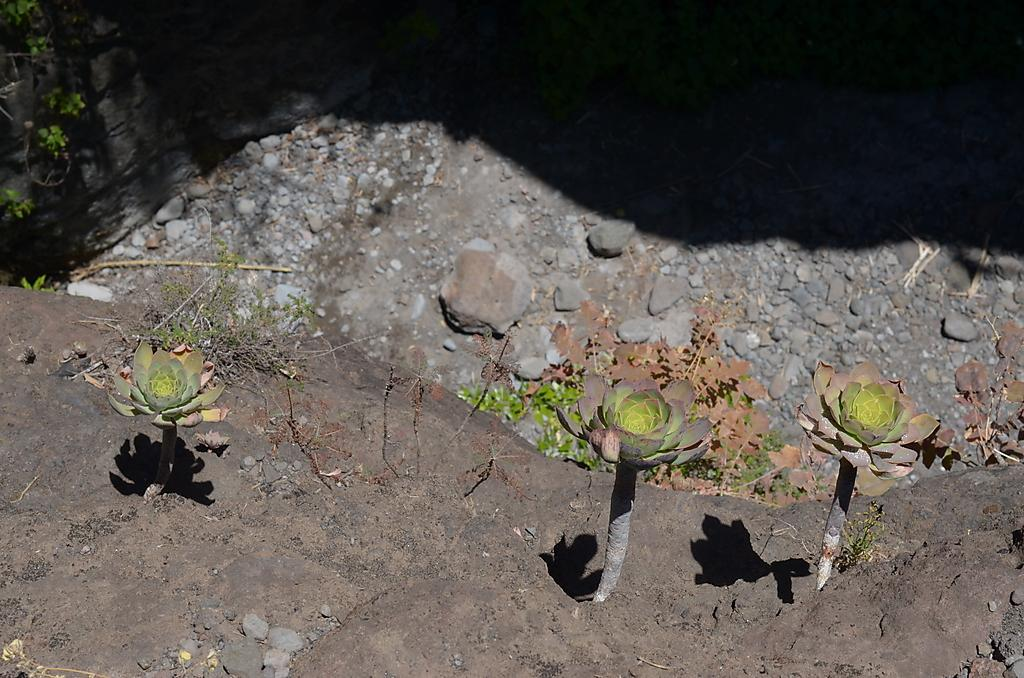What type of living organisms can be seen in the image? Plants can be seen in the image. What type of material is present on the ground in the image? There are stones on the ground in the image. What type of squirrel can be seen climbing the brick channel in the image? There is no squirrel or brick channel present in the image; it only features plants and stones on the ground. 